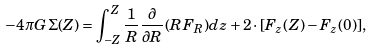<formula> <loc_0><loc_0><loc_500><loc_500>- 4 \pi G \Sigma ( Z ) = \int _ { - Z } ^ { Z } \frac { 1 } { R } \frac { \partial } { \partial R } ( R F _ { R } ) d z + 2 \cdot [ F _ { z } ( Z ) - F _ { z } ( 0 ) ] ,</formula> 